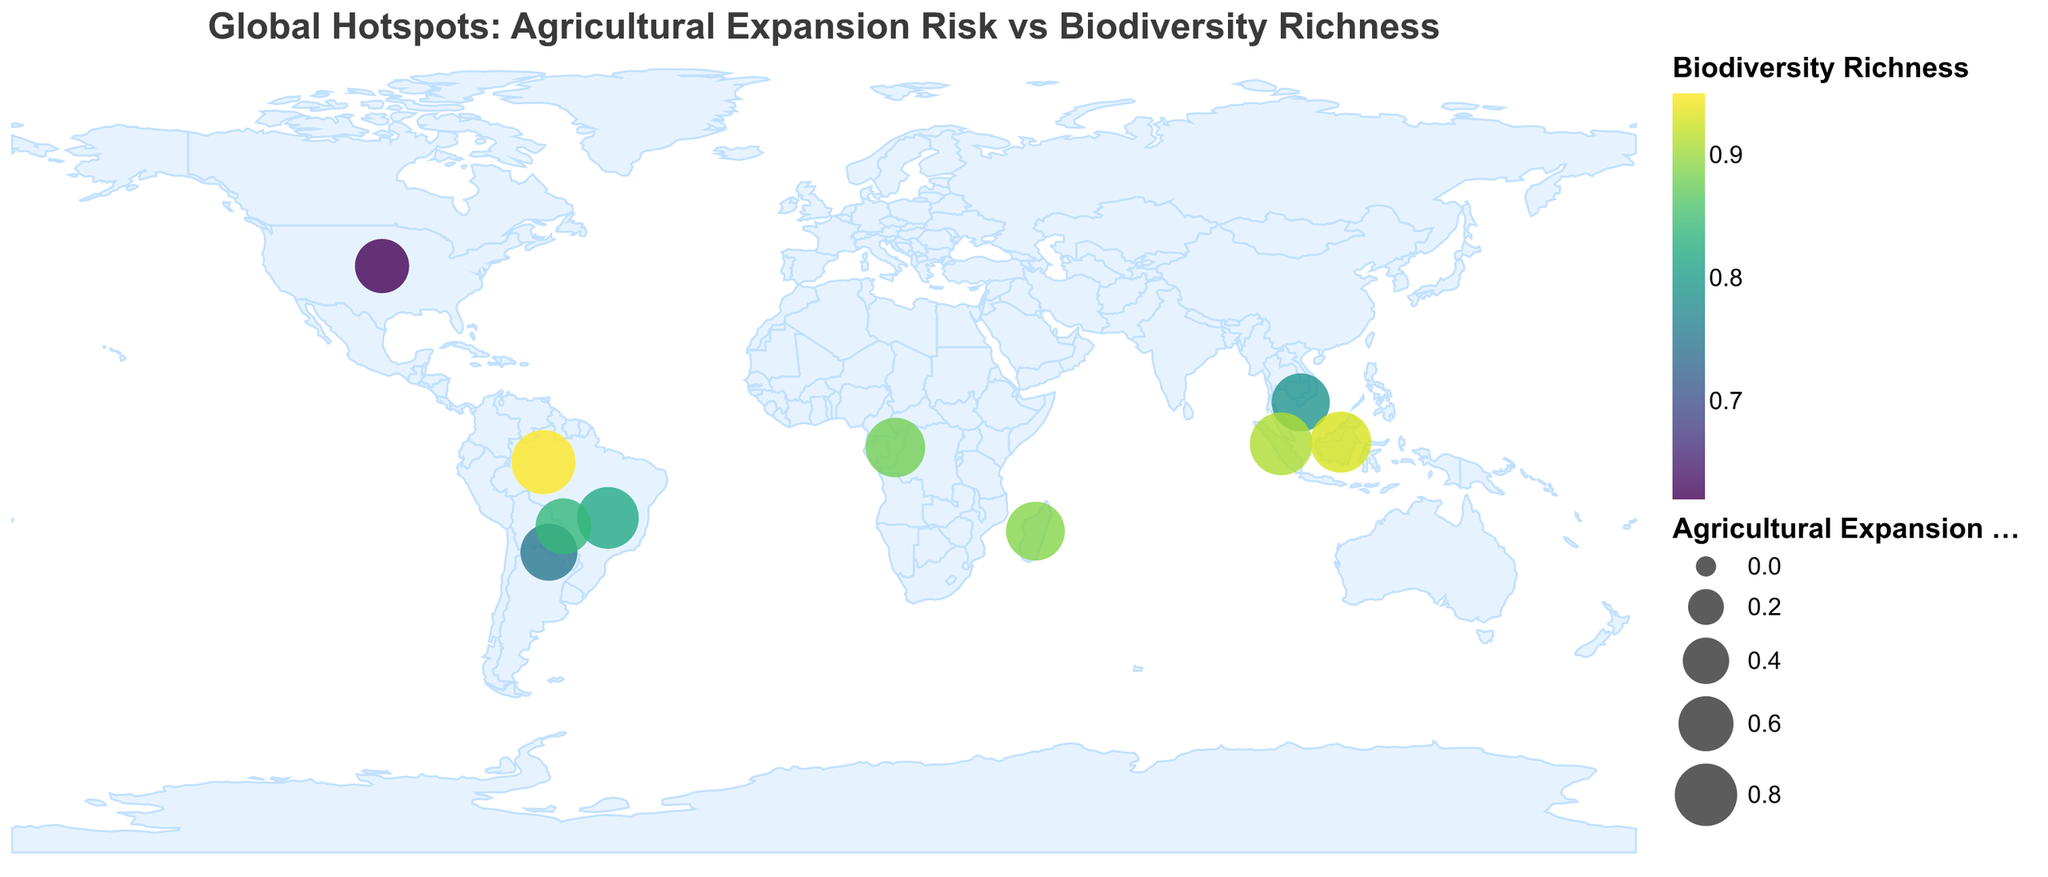What is the title of the figure? The title is usually one of the most prominently displayed pieces of text in a figure. Here, it reads "Global Hotspots: Agricultural Expansion Risk vs Biodiversity Richness" at the top of the figure.
Answer: Global Hotspots: Agricultural Expansion Risk vs Biodiversity Richness What color scheme is used to represent Biodiversity Richness? By looking at the color legend in the figure, the scheme used to display Biodiversity Richness appears to be a gradient of colors ranging from lighter to darker shades indicative of the 'viridis' color scheme.
Answer: Viridis How many regions are visualized in the figure? You can count the number of data points, each representing a region, which are marked by circles on the map. There are 10 regions represented.
Answer: 10 Which region has the highest Agricultural Expansion Risk? By examining the size of the circles, the largest circle represents the region with the highest Agricultural Expansion Risk. Based on the data tooltip, it is the Amazon Rainforest with a risk value of 0.85.
Answer: Amazon Rainforest Which region exhibits the highest Biodiversity Richness? Looking at the color intensity of the circles, the darkest color represents the highest Biodiversity Richness. The tooltip confirms that the Amazon Rainforest has the highest value of 0.95.
Answer: Amazon Rainforest Which region has the lowest Agricultural Expansion Risk? The smallest circle on the map indicates the lowest Agricultural Expansion Risk. According to the tooltip provided, the Great Plains (North America) has the lowest risk value of 0.58.
Answer: Great Plains (North America) What is the difference in Agricultural Expansion Risk between the Amazon Rainforest and the Great Plains? Subtract the Agricultural Expansion Risk of the Great Plains (0.58) from that of the Amazon Rainforest (0.85) using: 0.85 - 0.58. The difference is 0.27.
Answer: 0.27 Which regions have both an Agricultural Expansion Risk and Biodiversity Richness value higher than 0.80? Identify the regions where both the Agricultural Expansion Risk and Biodiversity Richness values are greater than 0.80. These regions from the data are: Amazon Rainforest, Cerrado (Brazil), Sumatran Lowlands, and Borneo. Confirm this by looking at the visual and tooltips.
Answer: Amazon Rainforest, Cerrado (Brazil), Sumatran Lowlands, Borneo What is the average Biodiversity Richness value for all the regions? Sum up the Biodiversity Richness values of all regions (0.95 + 0.82 + 0.88 + 0.79 + 0.91 + 0.93 + 0.89 + 0.75 + 0.62 + 0.84 = 8.38) and divide by the number of regions (10): 8.38 / 10. The average Biodiversity Richness is 0.838.
Answer: 0.838 